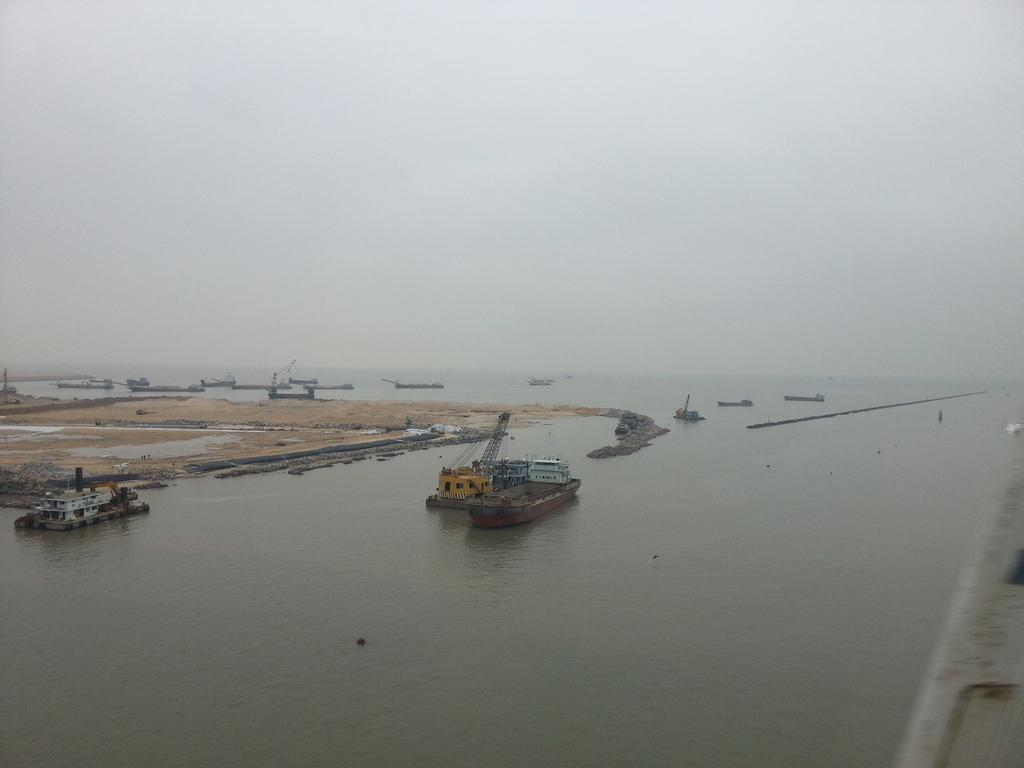What type of vehicles are docked in the water in the image? There are ships docked in the water in the image. What body of water are the ships docked in? The water is part of an ocean. What is the condition of the sky in the image? The sky is clear in the image. How many cows can be seen grazing on the shore in the image? There are no cows present in the image; it features ships docked in an ocean. What type of activity are the frogs participating in on the ships in the image? There are no frogs present in the image, so it is not possible to determine what activity they might be participating in. 